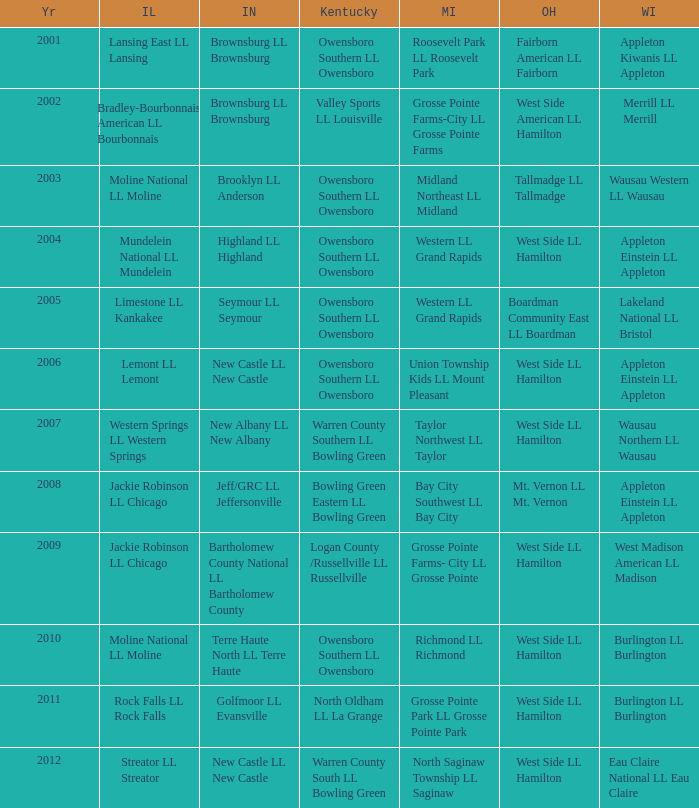What was the little league team from Kentucky when the little league team from Indiana and Wisconsin were Brownsburg LL Brownsburg and Merrill LL Merrill? Valley Sports LL Louisville. 